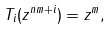Convert formula to latex. <formula><loc_0><loc_0><loc_500><loc_500>T _ { i } ( z ^ { n m + i } ) = z ^ { m } ,</formula> 